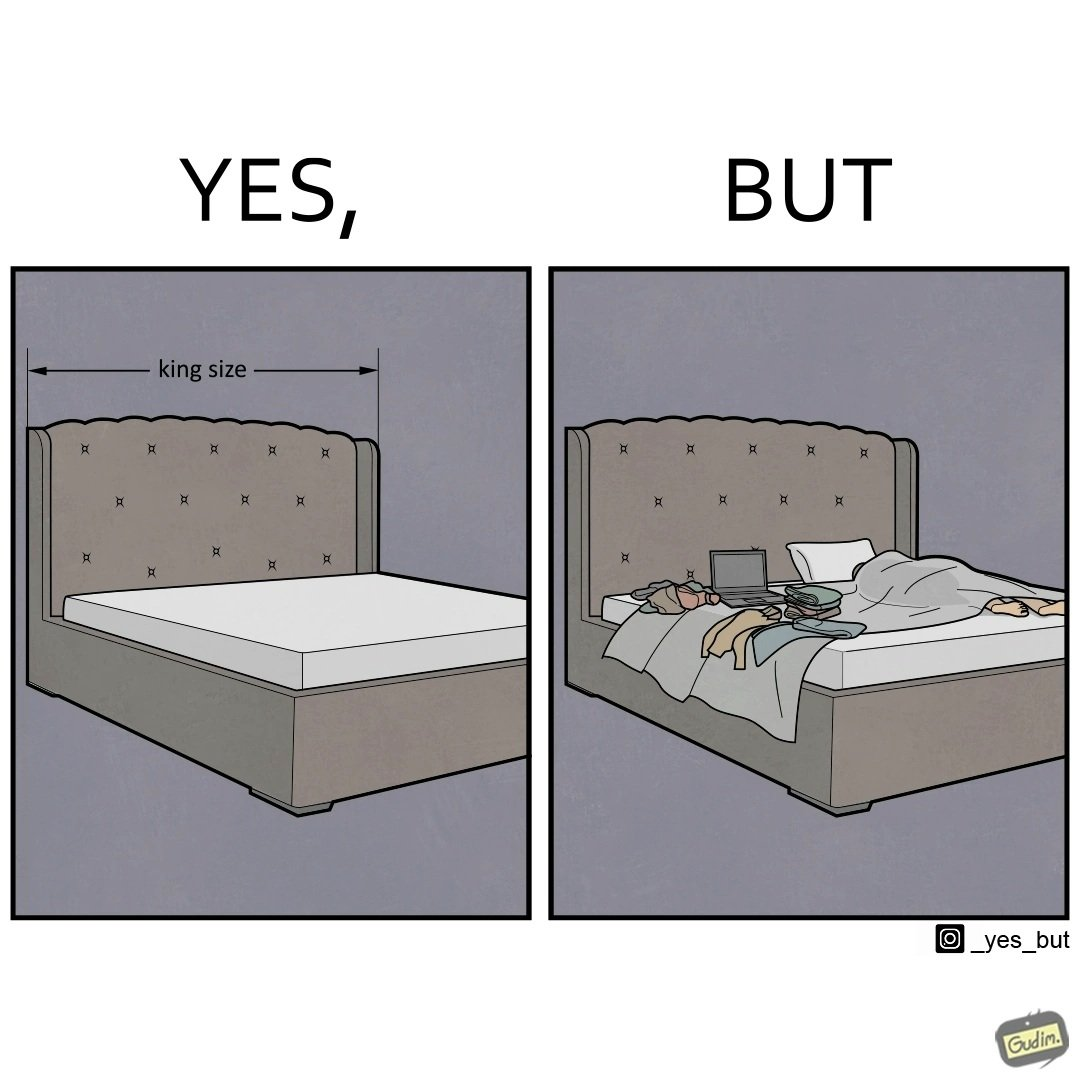Compare the left and right sides of this image. In the left part of the image: There is a bed of king size. In the right part of the image: There is a person sleeping with his material on its bed; 